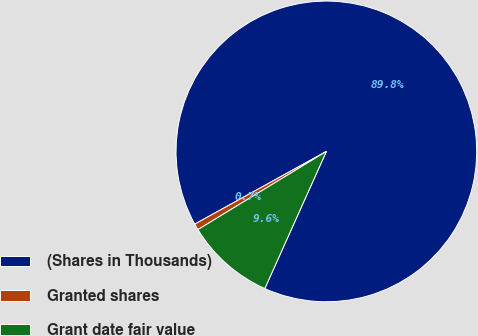<chart> <loc_0><loc_0><loc_500><loc_500><pie_chart><fcel>(Shares in Thousands)<fcel>Granted shares<fcel>Grant date fair value<nl><fcel>89.75%<fcel>0.67%<fcel>9.58%<nl></chart> 